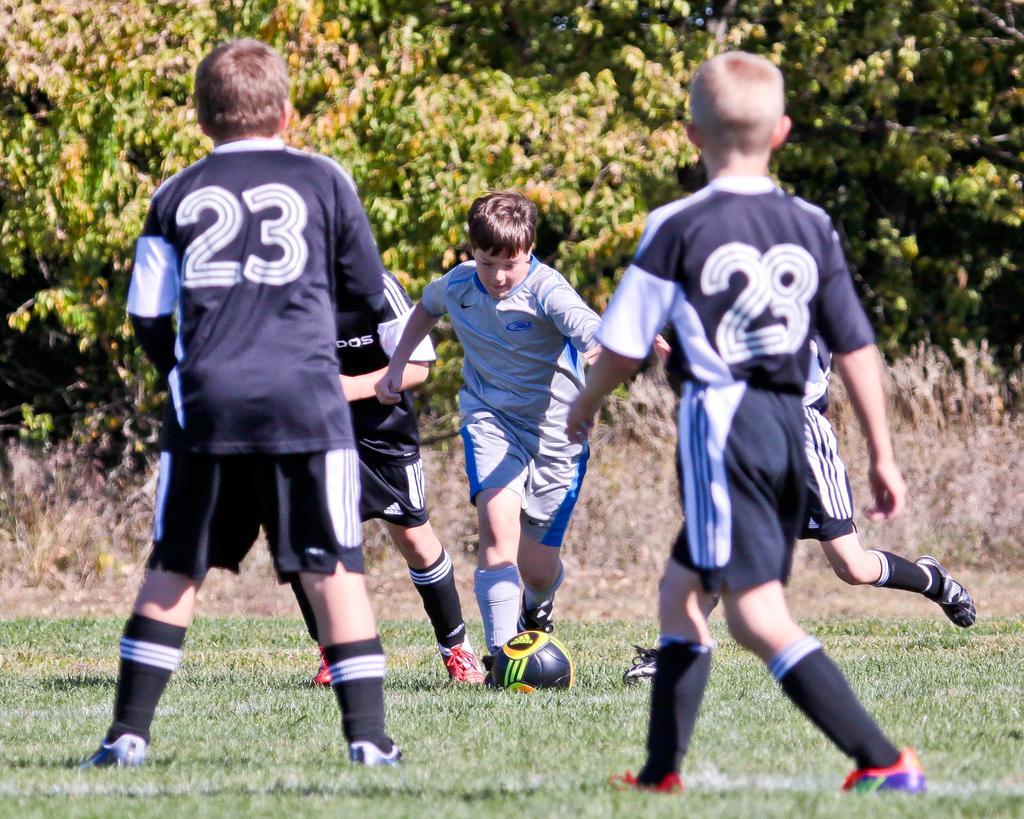Describe this image in one or two sentences. Five boys are playing football in the ground. Ground is full of grass. in the background there are some trees. There is a football on the ground. 